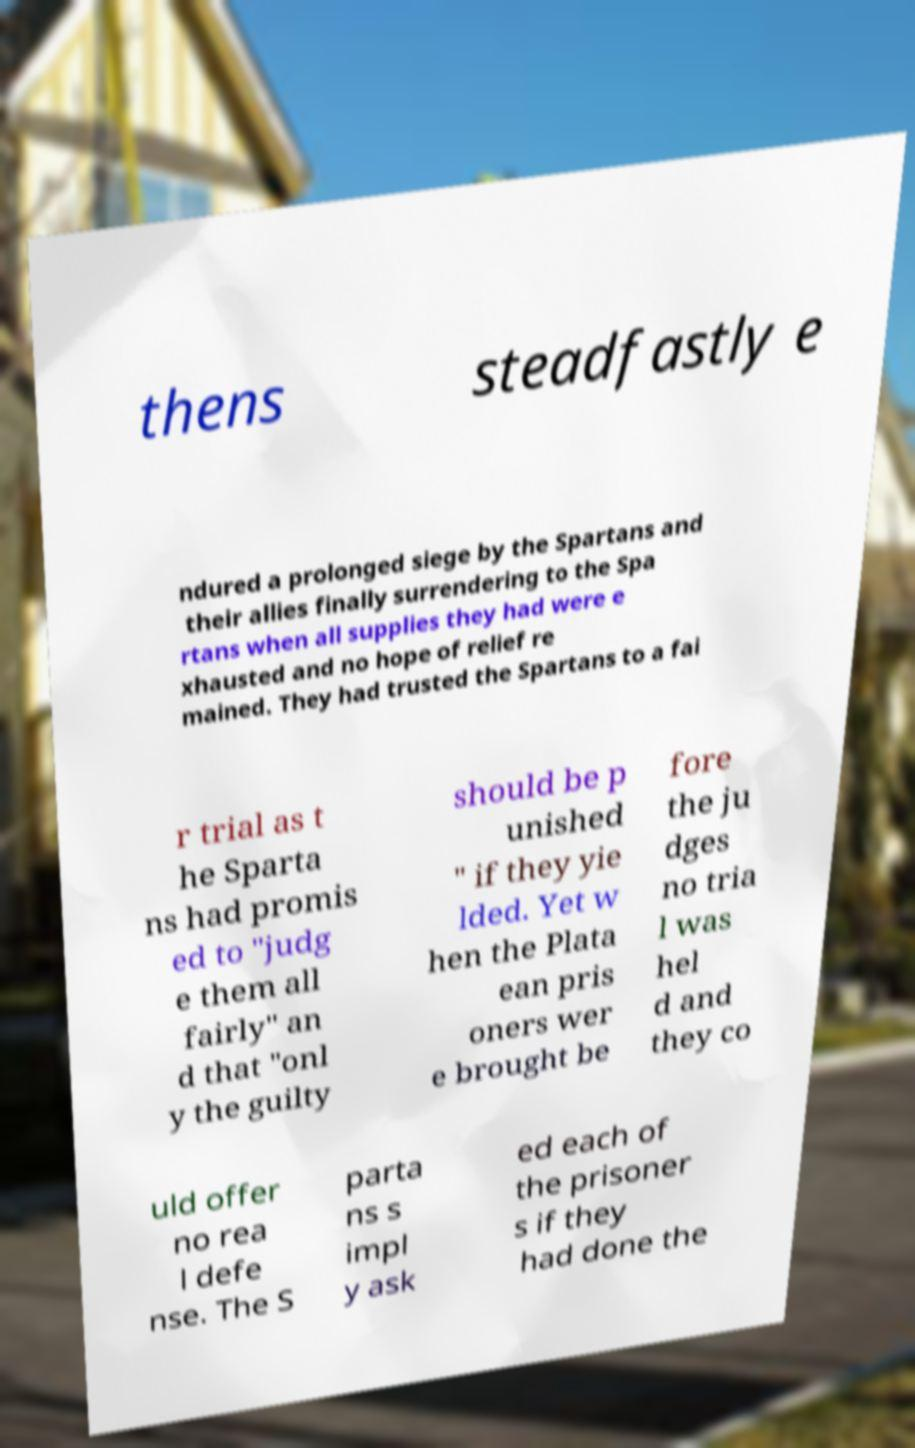Could you extract and type out the text from this image? thens steadfastly e ndured a prolonged siege by the Spartans and their allies finally surrendering to the Spa rtans when all supplies they had were e xhausted and no hope of relief re mained. They had trusted the Spartans to a fai r trial as t he Sparta ns had promis ed to "judg e them all fairly" an d that "onl y the guilty should be p unished " if they yie lded. Yet w hen the Plata ean pris oners wer e brought be fore the ju dges no tria l was hel d and they co uld offer no rea l defe nse. The S parta ns s impl y ask ed each of the prisoner s if they had done the 